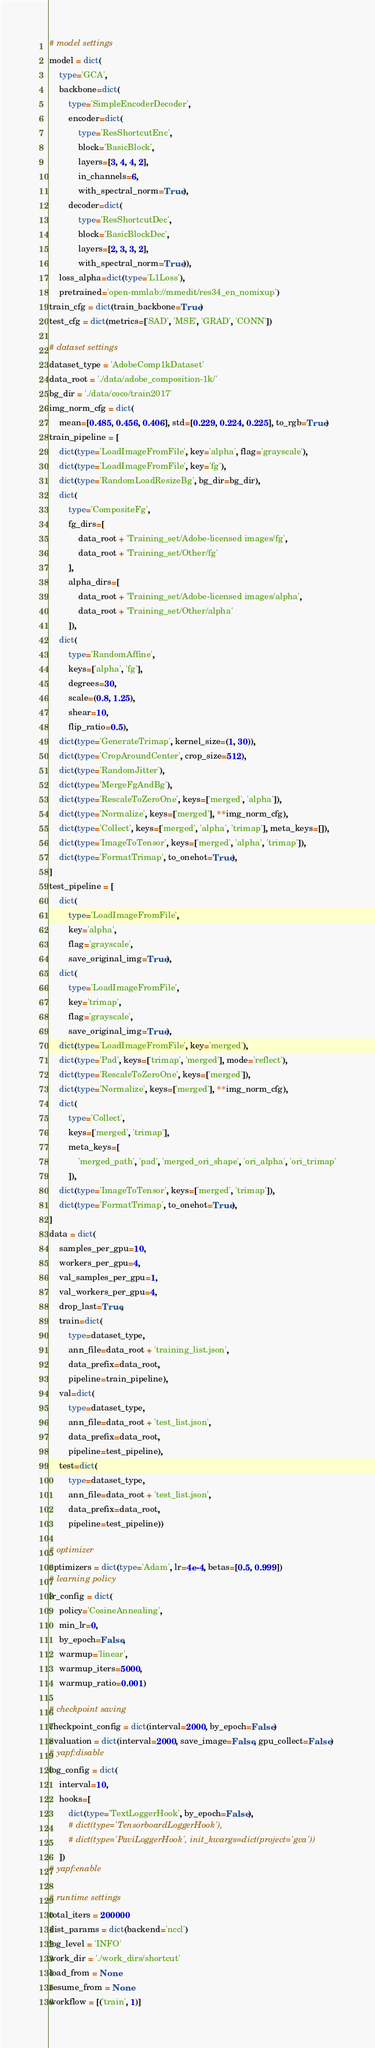<code> <loc_0><loc_0><loc_500><loc_500><_Python_># model settings
model = dict(
    type='GCA',
    backbone=dict(
        type='SimpleEncoderDecoder',
        encoder=dict(
            type='ResShortcutEnc',
            block='BasicBlock',
            layers=[3, 4, 4, 2],
            in_channels=6,
            with_spectral_norm=True),
        decoder=dict(
            type='ResShortcutDec',
            block='BasicBlockDec',
            layers=[2, 3, 3, 2],
            with_spectral_norm=True)),
    loss_alpha=dict(type='L1Loss'),
    pretrained='open-mmlab://mmedit/res34_en_nomixup')
train_cfg = dict(train_backbone=True)
test_cfg = dict(metrics=['SAD', 'MSE', 'GRAD', 'CONN'])

# dataset settings
dataset_type = 'AdobeComp1kDataset'
data_root = './data/adobe_composition-1k/'
bg_dir = './data/coco/train2017'
img_norm_cfg = dict(
    mean=[0.485, 0.456, 0.406], std=[0.229, 0.224, 0.225], to_rgb=True)
train_pipeline = [
    dict(type='LoadImageFromFile', key='alpha', flag='grayscale'),
    dict(type='LoadImageFromFile', key='fg'),
    dict(type='RandomLoadResizeBg', bg_dir=bg_dir),
    dict(
        type='CompositeFg',
        fg_dirs=[
            data_root + 'Training_set/Adobe-licensed images/fg',
            data_root + 'Training_set/Other/fg'
        ],
        alpha_dirs=[
            data_root + 'Training_set/Adobe-licensed images/alpha',
            data_root + 'Training_set/Other/alpha'
        ]),
    dict(
        type='RandomAffine',
        keys=['alpha', 'fg'],
        degrees=30,
        scale=(0.8, 1.25),
        shear=10,
        flip_ratio=0.5),
    dict(type='GenerateTrimap', kernel_size=(1, 30)),
    dict(type='CropAroundCenter', crop_size=512),
    dict(type='RandomJitter'),
    dict(type='MergeFgAndBg'),
    dict(type='RescaleToZeroOne', keys=['merged', 'alpha']),
    dict(type='Normalize', keys=['merged'], **img_norm_cfg),
    dict(type='Collect', keys=['merged', 'alpha', 'trimap'], meta_keys=[]),
    dict(type='ImageToTensor', keys=['merged', 'alpha', 'trimap']),
    dict(type='FormatTrimap', to_onehot=True),
]
test_pipeline = [
    dict(
        type='LoadImageFromFile',
        key='alpha',
        flag='grayscale',
        save_original_img=True),
    dict(
        type='LoadImageFromFile',
        key='trimap',
        flag='grayscale',
        save_original_img=True),
    dict(type='LoadImageFromFile', key='merged'),
    dict(type='Pad', keys=['trimap', 'merged'], mode='reflect'),
    dict(type='RescaleToZeroOne', keys=['merged']),
    dict(type='Normalize', keys=['merged'], **img_norm_cfg),
    dict(
        type='Collect',
        keys=['merged', 'trimap'],
        meta_keys=[
            'merged_path', 'pad', 'merged_ori_shape', 'ori_alpha', 'ori_trimap'
        ]),
    dict(type='ImageToTensor', keys=['merged', 'trimap']),
    dict(type='FormatTrimap', to_onehot=True),
]
data = dict(
    samples_per_gpu=10,
    workers_per_gpu=4,
    val_samples_per_gpu=1,
    val_workers_per_gpu=4,
    drop_last=True,
    train=dict(
        type=dataset_type,
        ann_file=data_root + 'training_list.json',
        data_prefix=data_root,
        pipeline=train_pipeline),
    val=dict(
        type=dataset_type,
        ann_file=data_root + 'test_list.json',
        data_prefix=data_root,
        pipeline=test_pipeline),
    test=dict(
        type=dataset_type,
        ann_file=data_root + 'test_list.json',
        data_prefix=data_root,
        pipeline=test_pipeline))

# optimizer
optimizers = dict(type='Adam', lr=4e-4, betas=[0.5, 0.999])
# learning policy
lr_config = dict(
    policy='CosineAnnealing',
    min_lr=0,
    by_epoch=False,
    warmup='linear',
    warmup_iters=5000,
    warmup_ratio=0.001)

# checkpoint saving
checkpoint_config = dict(interval=2000, by_epoch=False)
evaluation = dict(interval=2000, save_image=False, gpu_collect=False)
# yapf:disable
log_config = dict(
    interval=10,
    hooks=[
        dict(type='TextLoggerHook', by_epoch=False),
        # dict(type='TensorboardLoggerHook'),
        # dict(type='PaviLoggerHook', init_kwargs=dict(project='gca'))
    ])
# yapf:enable

# runtime settings
total_iters = 200000
dist_params = dict(backend='nccl')
log_level = 'INFO'
work_dir = './work_dirs/shortcut'
load_from = None
resume_from = None
workflow = [('train', 1)]
</code> 